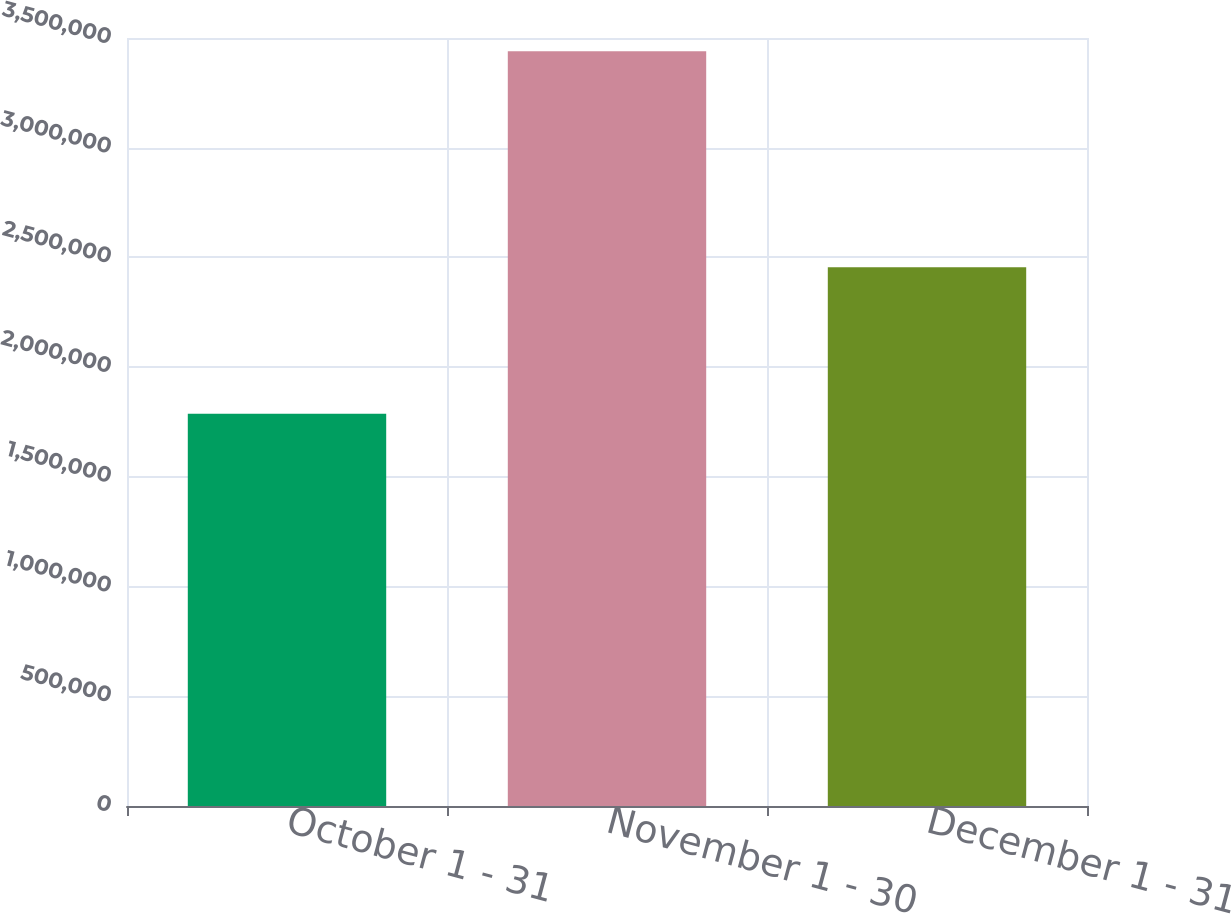Convert chart to OTSL. <chart><loc_0><loc_0><loc_500><loc_500><bar_chart><fcel>October 1 - 31<fcel>November 1 - 30<fcel>December 1 - 31<nl><fcel>1.7874e+06<fcel>3.43978e+06<fcel>2.45481e+06<nl></chart> 